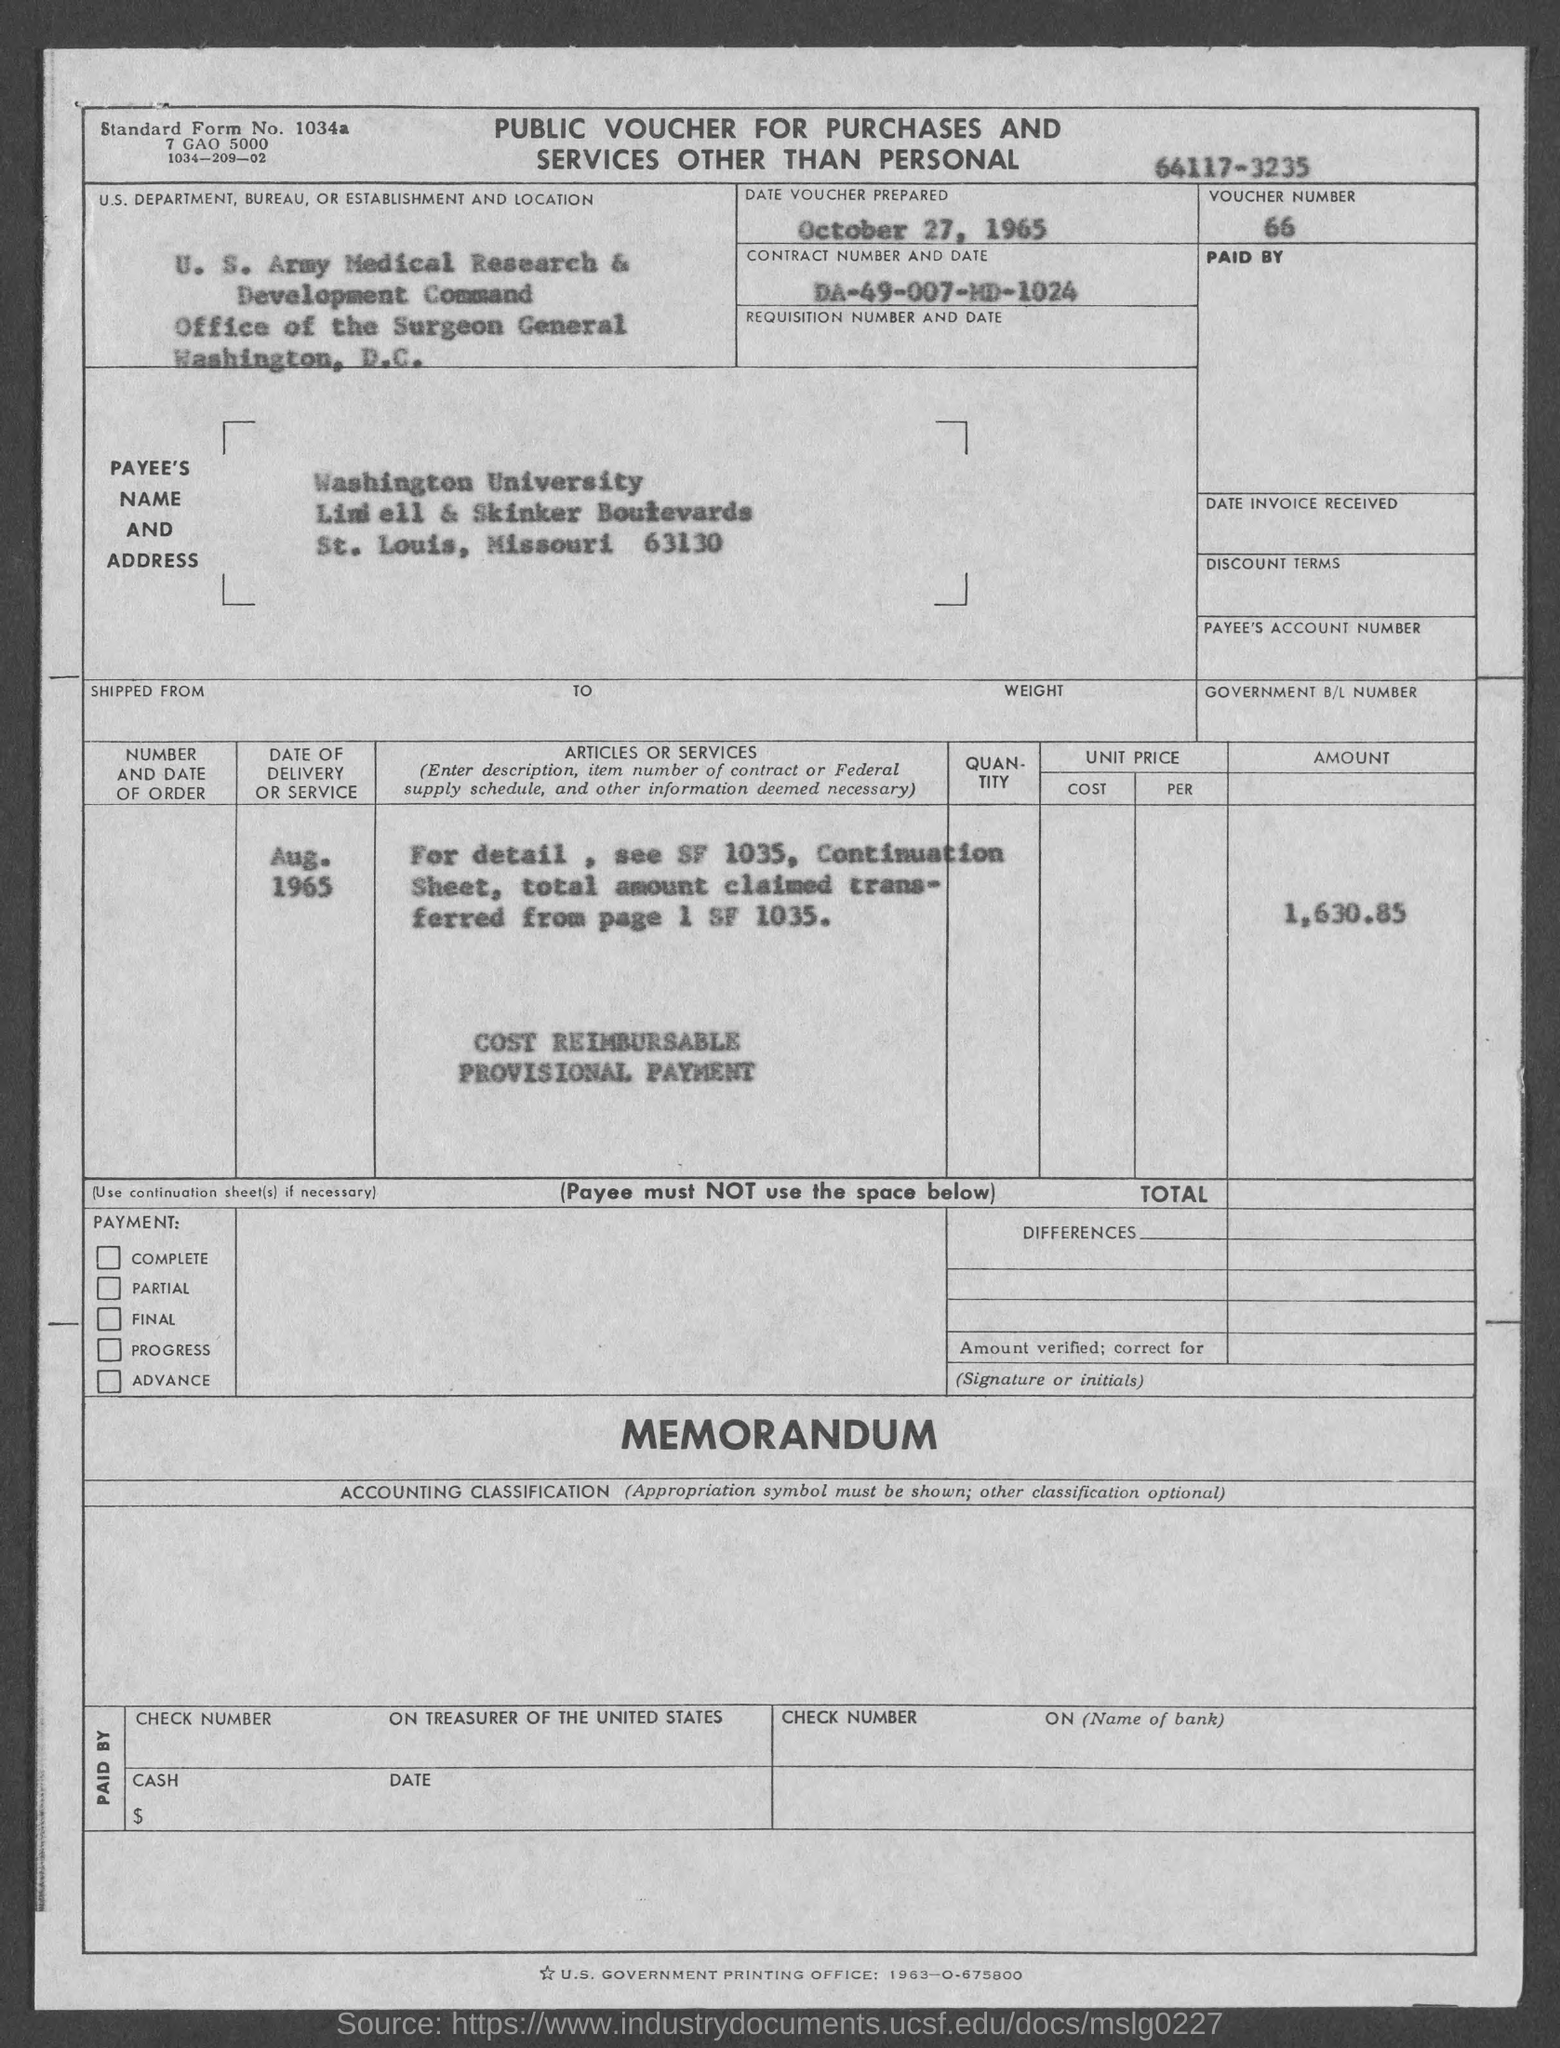What is the voucher number ?
Offer a very short reply. 66. When is the date voucher prepared ?
Offer a very short reply. October 27, 1965. What is the payee's name ?
Your answer should be very brief. Washington University. 